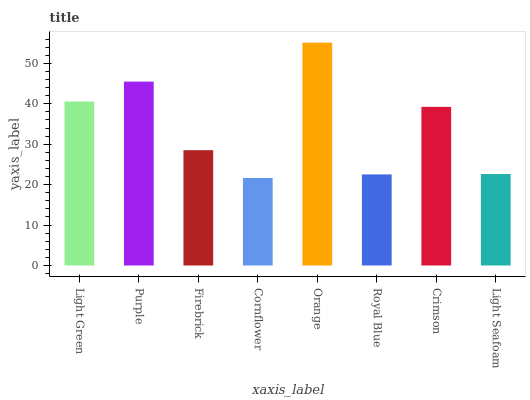Is Purple the minimum?
Answer yes or no. No. Is Purple the maximum?
Answer yes or no. No. Is Purple greater than Light Green?
Answer yes or no. Yes. Is Light Green less than Purple?
Answer yes or no. Yes. Is Light Green greater than Purple?
Answer yes or no. No. Is Purple less than Light Green?
Answer yes or no. No. Is Crimson the high median?
Answer yes or no. Yes. Is Firebrick the low median?
Answer yes or no. Yes. Is Purple the high median?
Answer yes or no. No. Is Purple the low median?
Answer yes or no. No. 